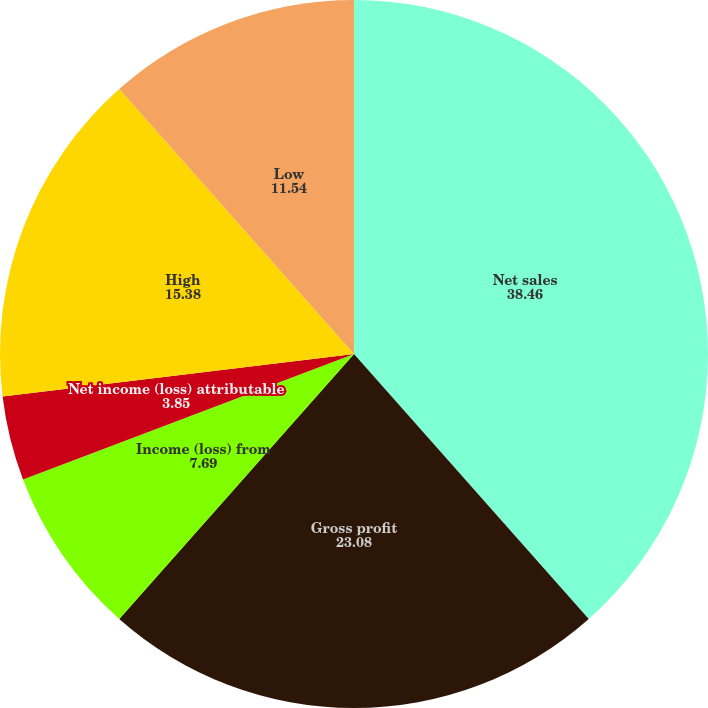<chart> <loc_0><loc_0><loc_500><loc_500><pie_chart><fcel>Net sales<fcel>Gross profit<fcel>Income (loss) from<fcel>Net income (loss) attributable<fcel>Dividends declared per common<fcel>High<fcel>Low<nl><fcel>38.46%<fcel>23.08%<fcel>7.69%<fcel>3.85%<fcel>0.0%<fcel>15.38%<fcel>11.54%<nl></chart> 